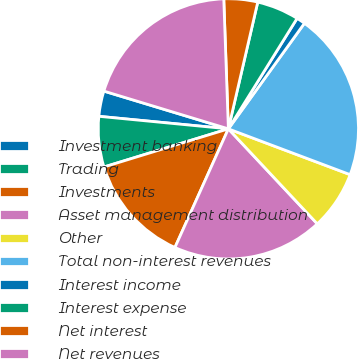Convert chart. <chart><loc_0><loc_0><loc_500><loc_500><pie_chart><fcel>Investment banking<fcel>Trading<fcel>Investments<fcel>Asset management distribution<fcel>Other<fcel>Total non-interest revenues<fcel>Interest income<fcel>Interest expense<fcel>Net interest<fcel>Net revenues<nl><fcel>3.15%<fcel>6.27%<fcel>13.53%<fcel>18.71%<fcel>7.3%<fcel>20.79%<fcel>1.08%<fcel>5.23%<fcel>4.19%<fcel>19.75%<nl></chart> 